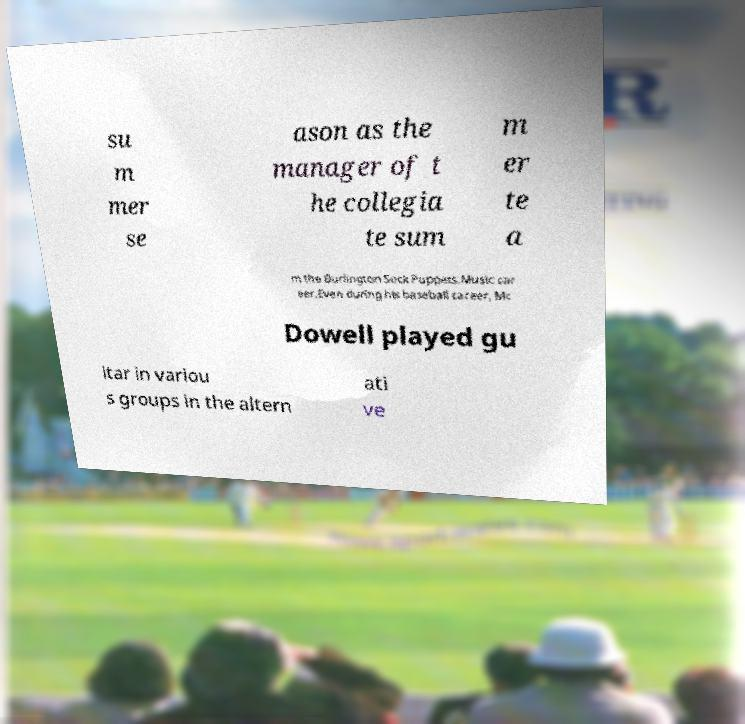Could you assist in decoding the text presented in this image and type it out clearly? su m mer se ason as the manager of t he collegia te sum m er te a m the Burlington Sock Puppets.Music car eer.Even during his baseball career, Mc Dowell played gu itar in variou s groups in the altern ati ve 